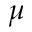<formula> <loc_0><loc_0><loc_500><loc_500>\mu</formula> 